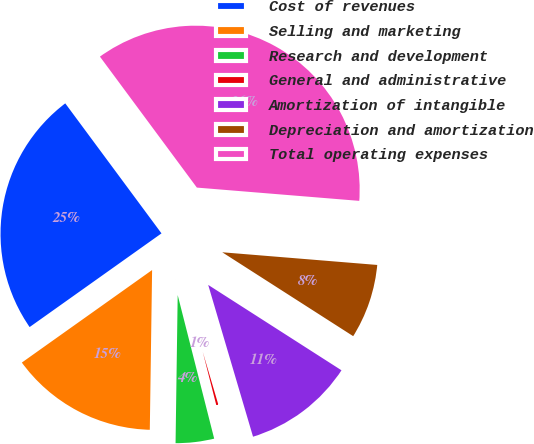<chart> <loc_0><loc_0><loc_500><loc_500><pie_chart><fcel>Cost of revenues<fcel>Selling and marketing<fcel>Research and development<fcel>General and administrative<fcel>Amortization of intangible<fcel>Depreciation and amortization<fcel>Total operating expenses<nl><fcel>24.69%<fcel>14.94%<fcel>4.19%<fcel>0.61%<fcel>11.36%<fcel>7.77%<fcel>36.44%<nl></chart> 